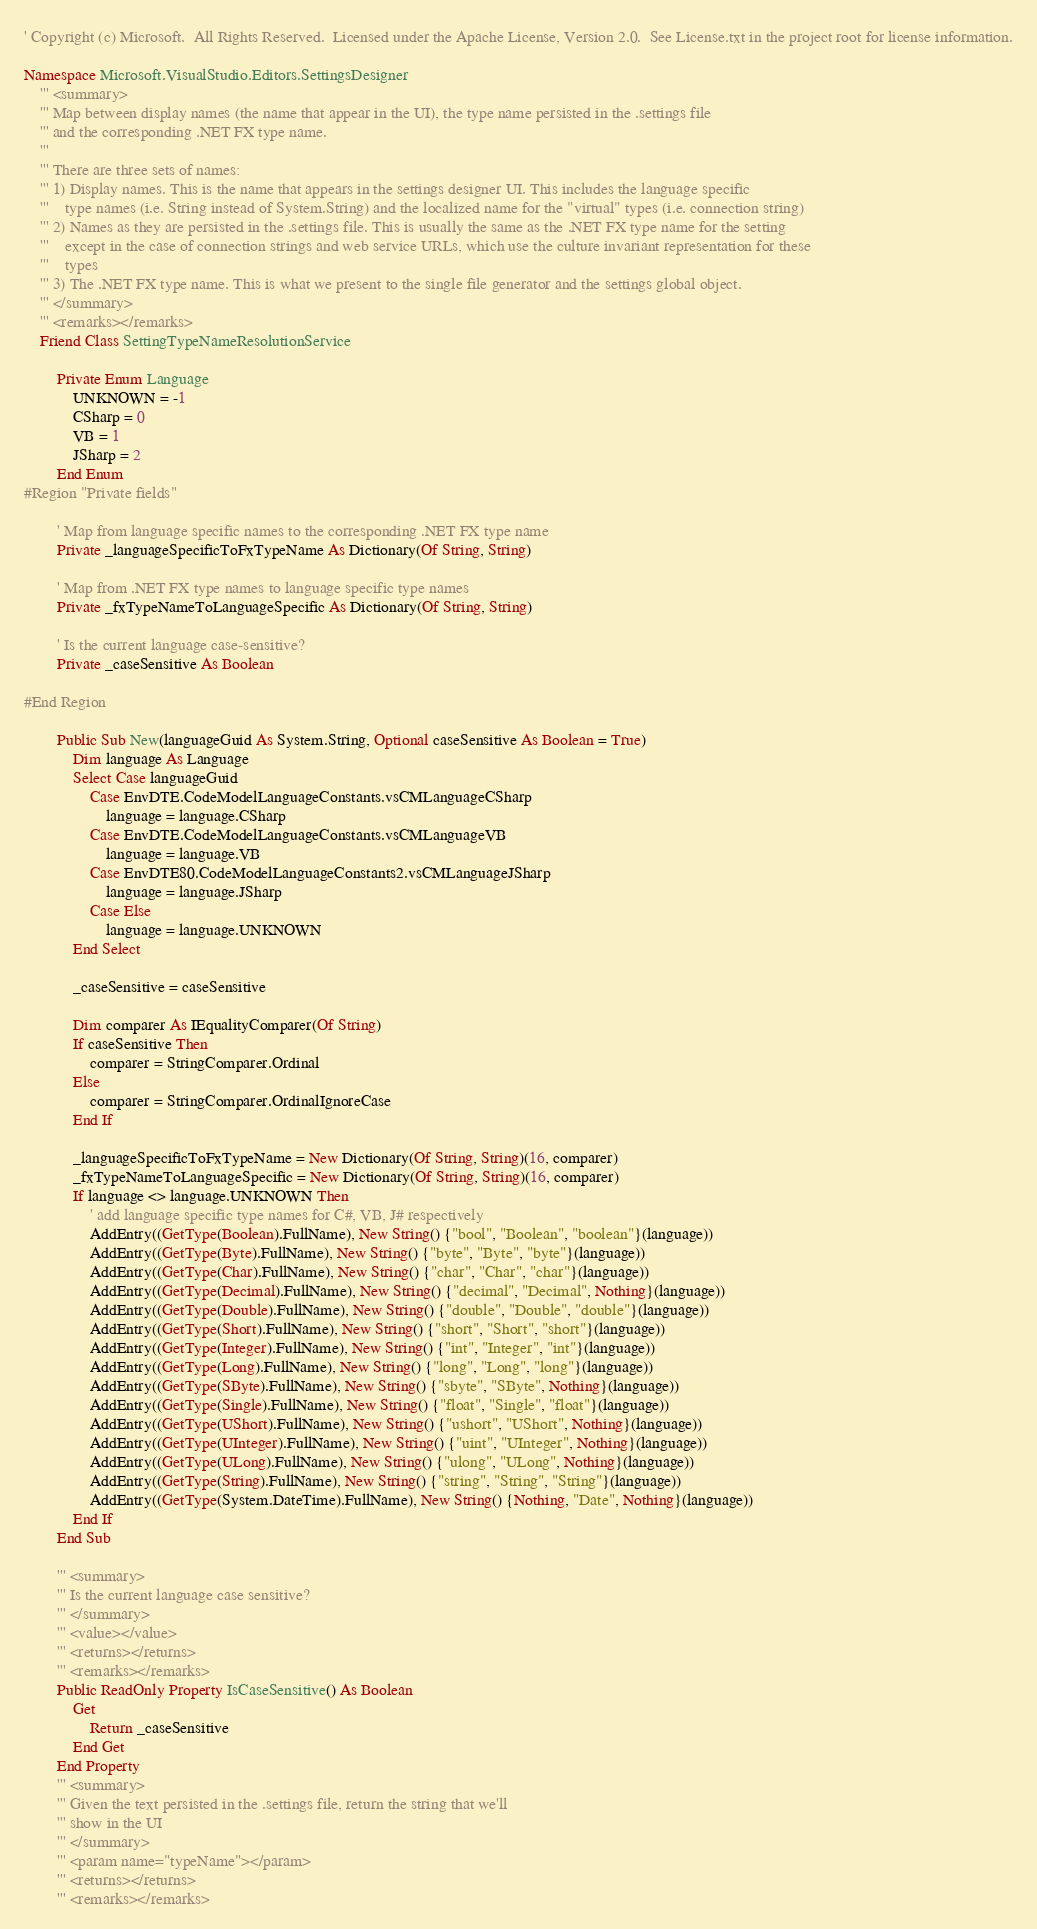Convert code to text. <code><loc_0><loc_0><loc_500><loc_500><_VisualBasic_>' Copyright (c) Microsoft.  All Rights Reserved.  Licensed under the Apache License, Version 2.0.  See License.txt in the project root for license information.

Namespace Microsoft.VisualStudio.Editors.SettingsDesigner
    ''' <summary>
    ''' Map between display names (the name that appear in the UI), the type name persisted in the .settings file
    ''' and the corresponding .NET FX type name.
    ''' 
    ''' There are three sets of names:
    ''' 1) Display names. This is the name that appears in the settings designer UI. This includes the language specific 
    '''    type names (i.e. String instead of System.String) and the localized name for the "virtual" types (i.e. connection string)
    ''' 2) Names as they are persisted in the .settings file. This is usually the same as the .NET FX type name for the setting
    '''    except in the case of connection strings and web service URLs, which use the culture invariant representation for these
    '''    types
    ''' 3) The .NET FX type name. This is what we present to the single file generator and the settings global object.
    ''' </summary>
    ''' <remarks></remarks>
    Friend Class SettingTypeNameResolutionService

        Private Enum Language
            UNKNOWN = -1
            CSharp = 0
            VB = 1
            JSharp = 2
        End Enum
#Region "Private fields"

        ' Map from language specific names to the corresponding .NET FX type name
        Private _languageSpecificToFxTypeName As Dictionary(Of String, String)

        ' Map from .NET FX type names to language specific type names
        Private _fxTypeNameToLanguageSpecific As Dictionary(Of String, String)

        ' Is the current language case-sensitive?
        Private _caseSensitive As Boolean

#End Region

        Public Sub New(languageGuid As System.String, Optional caseSensitive As Boolean = True)
            Dim language As Language
            Select Case languageGuid
                Case EnvDTE.CodeModelLanguageConstants.vsCMLanguageCSharp
                    language = language.CSharp
                Case EnvDTE.CodeModelLanguageConstants.vsCMLanguageVB
                    language = language.VB
                Case EnvDTE80.CodeModelLanguageConstants2.vsCMLanguageJSharp
                    language = language.JSharp
                Case Else
                    language = language.UNKNOWN
            End Select

            _caseSensitive = caseSensitive

            Dim comparer As IEqualityComparer(Of String)
            If caseSensitive Then
                comparer = StringComparer.Ordinal
            Else
                comparer = StringComparer.OrdinalIgnoreCase
            End If

            _languageSpecificToFxTypeName = New Dictionary(Of String, String)(16, comparer)
            _fxTypeNameToLanguageSpecific = New Dictionary(Of String, String)(16, comparer)
            If language <> language.UNKNOWN Then
                ' add language specific type names for C#, VB, J# respectively
                AddEntry((GetType(Boolean).FullName), New String() {"bool", "Boolean", "boolean"}(language))
                AddEntry((GetType(Byte).FullName), New String() {"byte", "Byte", "byte"}(language))
                AddEntry((GetType(Char).FullName), New String() {"char", "Char", "char"}(language))
                AddEntry((GetType(Decimal).FullName), New String() {"decimal", "Decimal", Nothing}(language))
                AddEntry((GetType(Double).FullName), New String() {"double", "Double", "double"}(language))
                AddEntry((GetType(Short).FullName), New String() {"short", "Short", "short"}(language))
                AddEntry((GetType(Integer).FullName), New String() {"int", "Integer", "int"}(language))
                AddEntry((GetType(Long).FullName), New String() {"long", "Long", "long"}(language))
                AddEntry((GetType(SByte).FullName), New String() {"sbyte", "SByte", Nothing}(language))
                AddEntry((GetType(Single).FullName), New String() {"float", "Single", "float"}(language))
                AddEntry((GetType(UShort).FullName), New String() {"ushort", "UShort", Nothing}(language))
                AddEntry((GetType(UInteger).FullName), New String() {"uint", "UInteger", Nothing}(language))
                AddEntry((GetType(ULong).FullName), New String() {"ulong", "ULong", Nothing}(language))
                AddEntry((GetType(String).FullName), New String() {"string", "String", "String"}(language))
                AddEntry((GetType(System.DateTime).FullName), New String() {Nothing, "Date", Nothing}(language))
            End If
        End Sub

        ''' <summary>
        ''' Is the current language case sensitive?
        ''' </summary>
        ''' <value></value>
        ''' <returns></returns>
        ''' <remarks></remarks>
        Public ReadOnly Property IsCaseSensitive() As Boolean
            Get
                Return _caseSensitive
            End Get
        End Property
        ''' <summary>
        ''' Given the text persisted in the .settings file, return the string that we'll 
        ''' show in the UI
        ''' </summary>
        ''' <param name="typeName"></param>
        ''' <returns></returns>
        ''' <remarks></remarks></code> 